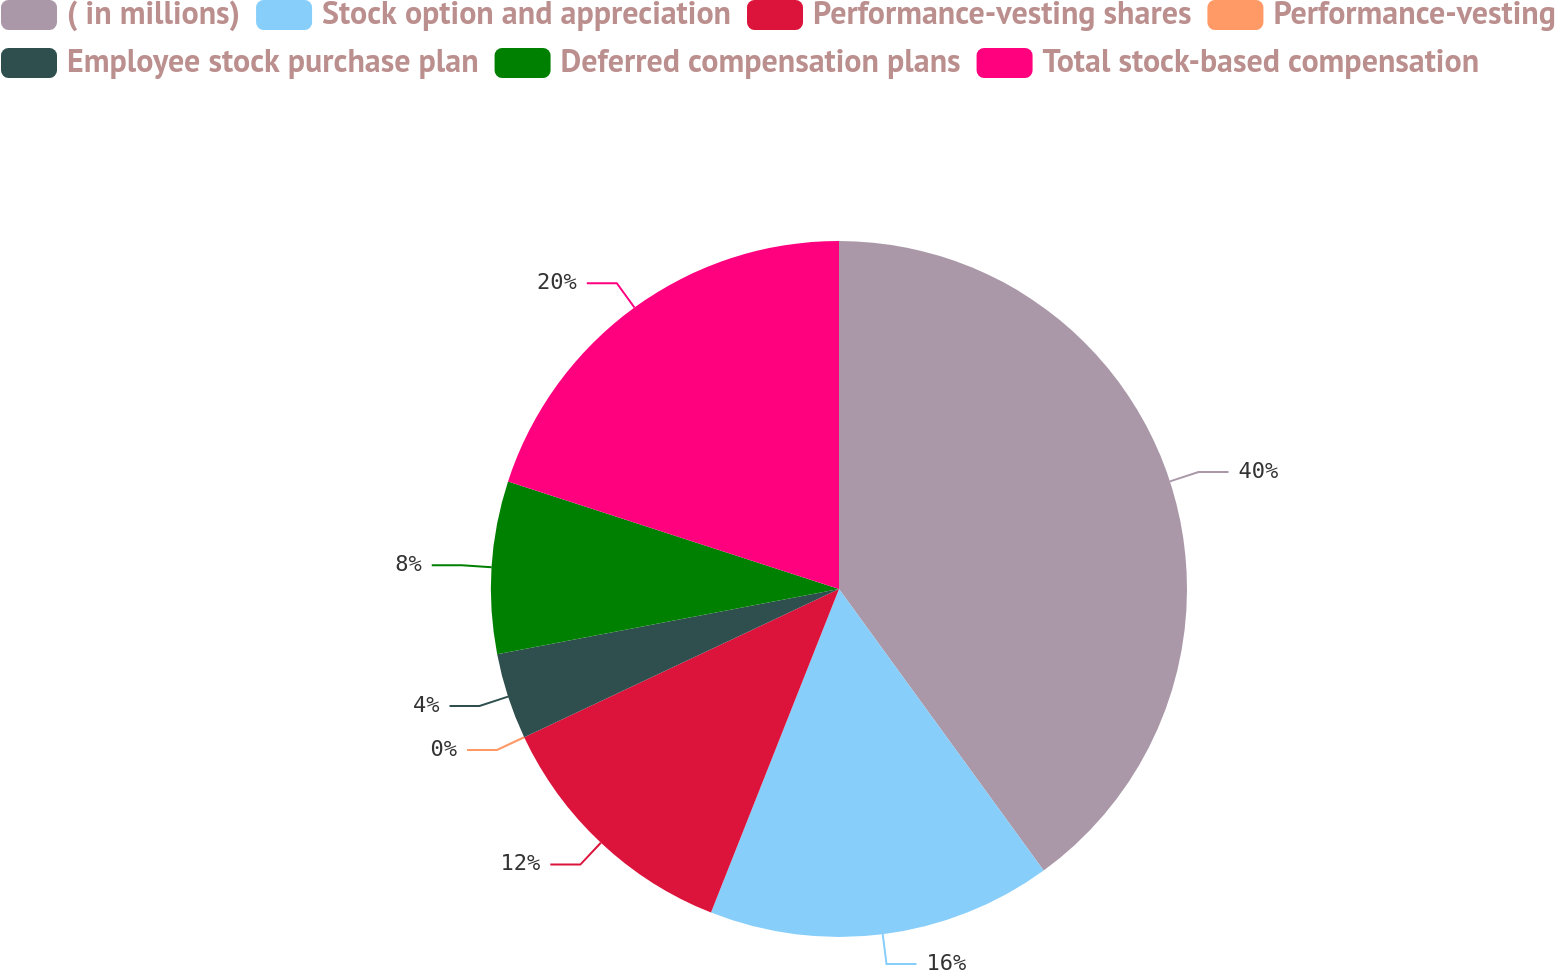Convert chart to OTSL. <chart><loc_0><loc_0><loc_500><loc_500><pie_chart><fcel>( in millions)<fcel>Stock option and appreciation<fcel>Performance-vesting shares<fcel>Performance-vesting<fcel>Employee stock purchase plan<fcel>Deferred compensation plans<fcel>Total stock-based compensation<nl><fcel>39.99%<fcel>16.0%<fcel>12.0%<fcel>0.0%<fcel>4.0%<fcel>8.0%<fcel>20.0%<nl></chart> 